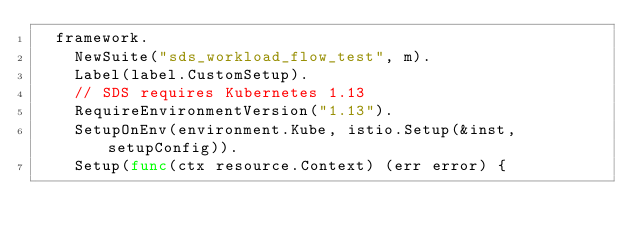Convert code to text. <code><loc_0><loc_0><loc_500><loc_500><_Go_>	framework.
		NewSuite("sds_workload_flow_test", m).
		Label(label.CustomSetup).
		// SDS requires Kubernetes 1.13
		RequireEnvironmentVersion("1.13").
		SetupOnEnv(environment.Kube, istio.Setup(&inst, setupConfig)).
		Setup(func(ctx resource.Context) (err error) {</code> 